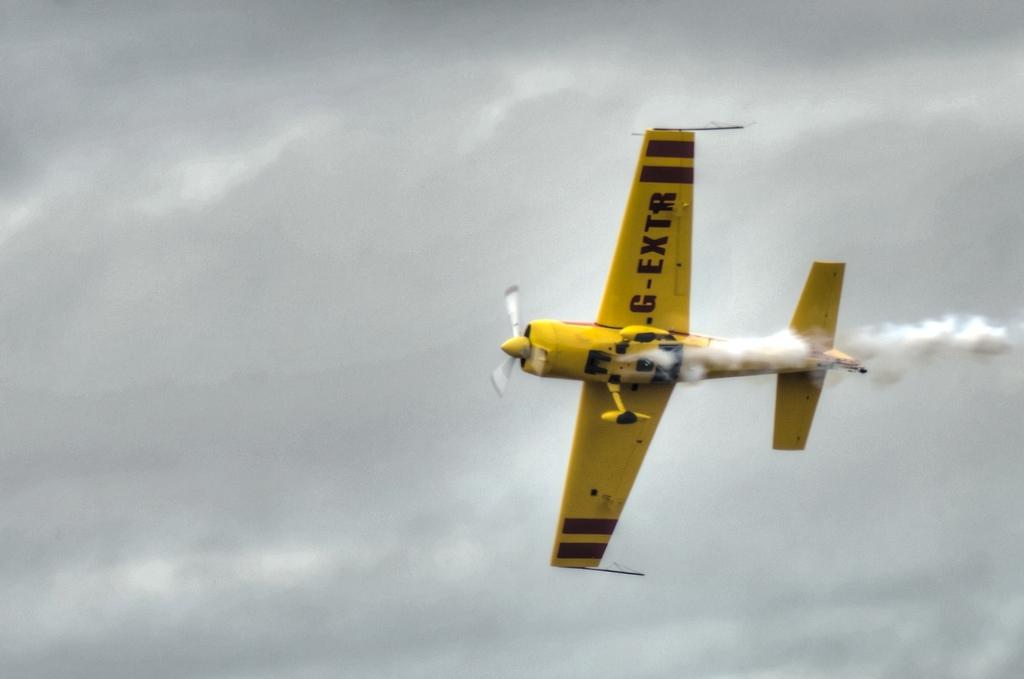What type of plane is this?
Provide a short and direct response. G-extr. 